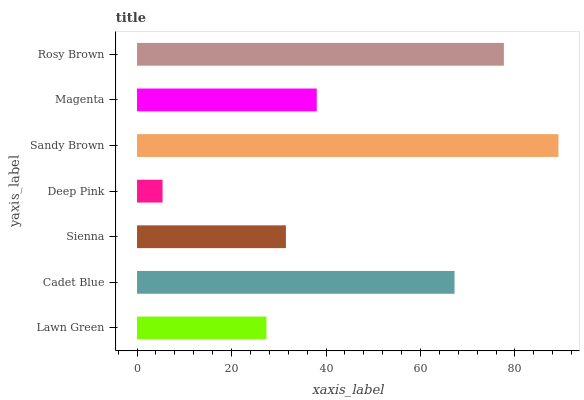Is Deep Pink the minimum?
Answer yes or no. Yes. Is Sandy Brown the maximum?
Answer yes or no. Yes. Is Cadet Blue the minimum?
Answer yes or no. No. Is Cadet Blue the maximum?
Answer yes or no. No. Is Cadet Blue greater than Lawn Green?
Answer yes or no. Yes. Is Lawn Green less than Cadet Blue?
Answer yes or no. Yes. Is Lawn Green greater than Cadet Blue?
Answer yes or no. No. Is Cadet Blue less than Lawn Green?
Answer yes or no. No. Is Magenta the high median?
Answer yes or no. Yes. Is Magenta the low median?
Answer yes or no. Yes. Is Lawn Green the high median?
Answer yes or no. No. Is Lawn Green the low median?
Answer yes or no. No. 